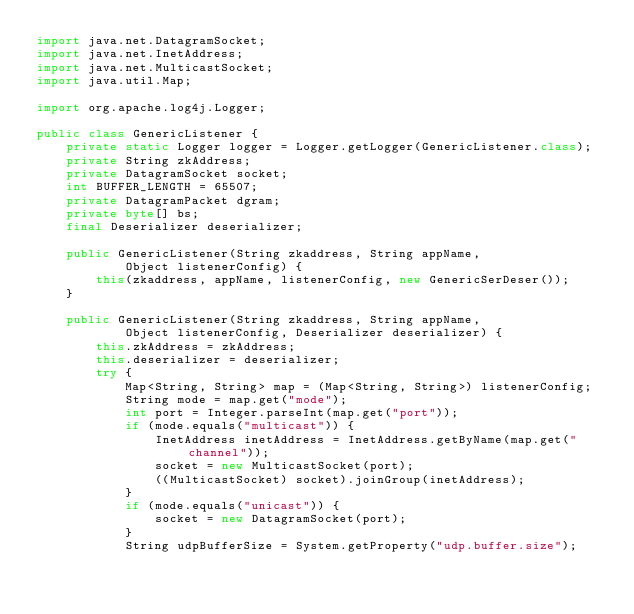<code> <loc_0><loc_0><loc_500><loc_500><_Java_>import java.net.DatagramSocket;
import java.net.InetAddress;
import java.net.MulticastSocket;
import java.util.Map;

import org.apache.log4j.Logger;

public class GenericListener {
    private static Logger logger = Logger.getLogger(GenericListener.class);
    private String zkAddress;
    private DatagramSocket socket;
    int BUFFER_LENGTH = 65507;
    private DatagramPacket dgram;
    private byte[] bs;
    final Deserializer deserializer;

    public GenericListener(String zkaddress, String appName,
            Object listenerConfig) {
        this(zkaddress, appName, listenerConfig, new GenericSerDeser());
    }

    public GenericListener(String zkaddress, String appName,
            Object listenerConfig, Deserializer deserializer) {
        this.zkAddress = zkAddress;
        this.deserializer = deserializer;
        try {
            Map<String, String> map = (Map<String, String>) listenerConfig;
            String mode = map.get("mode");
            int port = Integer.parseInt(map.get("port"));
            if (mode.equals("multicast")) {
                InetAddress inetAddress = InetAddress.getByName(map.get("channel"));
                socket = new MulticastSocket(port);
                ((MulticastSocket) socket).joinGroup(inetAddress);
            }
            if (mode.equals("unicast")) {
                socket = new DatagramSocket(port);
            }
            String udpBufferSize = System.getProperty("udp.buffer.size");</code> 